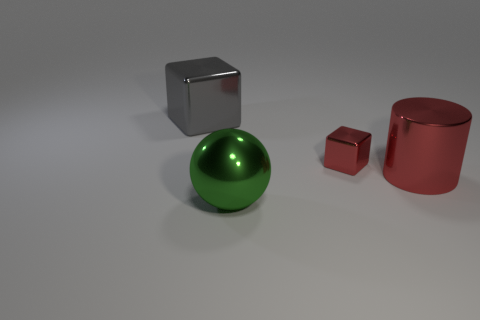How big is the metal thing that is behind the large red metallic thing and in front of the gray thing?
Provide a short and direct response. Small. How big is the shiny block that is on the right side of the object that is in front of the big thing that is right of the green metallic ball?
Provide a succinct answer. Small. Do the red shiny object that is left of the metallic cylinder and the metallic thing that is left of the large green metal ball have the same size?
Give a very brief answer. No. Is there any other thing that has the same shape as the green object?
Provide a succinct answer. No. Is the tiny red metal object the same shape as the gray object?
Keep it short and to the point. Yes. How many spheres have the same size as the red metal cylinder?
Keep it short and to the point. 1. Are there fewer tiny shiny things that are on the left side of the cylinder than shiny cubes?
Provide a succinct answer. Yes. There is a metallic block right of the thing to the left of the large green sphere; how big is it?
Ensure brevity in your answer.  Small. What number of things are small blocks or big matte objects?
Offer a terse response. 1. Is there another object that has the same color as the tiny object?
Offer a terse response. Yes. 